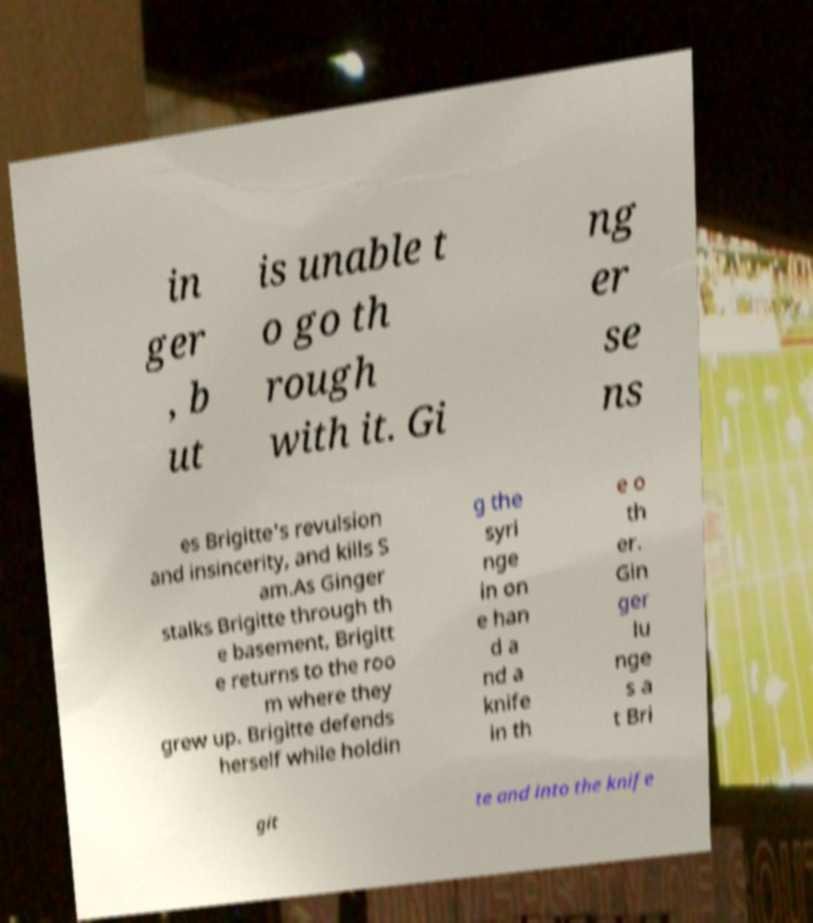For documentation purposes, I need the text within this image transcribed. Could you provide that? in ger , b ut is unable t o go th rough with it. Gi ng er se ns es Brigitte's revulsion and insincerity, and kills S am.As Ginger stalks Brigitte through th e basement, Brigitt e returns to the roo m where they grew up. Brigitte defends herself while holdin g the syri nge in on e han d a nd a knife in th e o th er. Gin ger lu nge s a t Bri git te and into the knife 